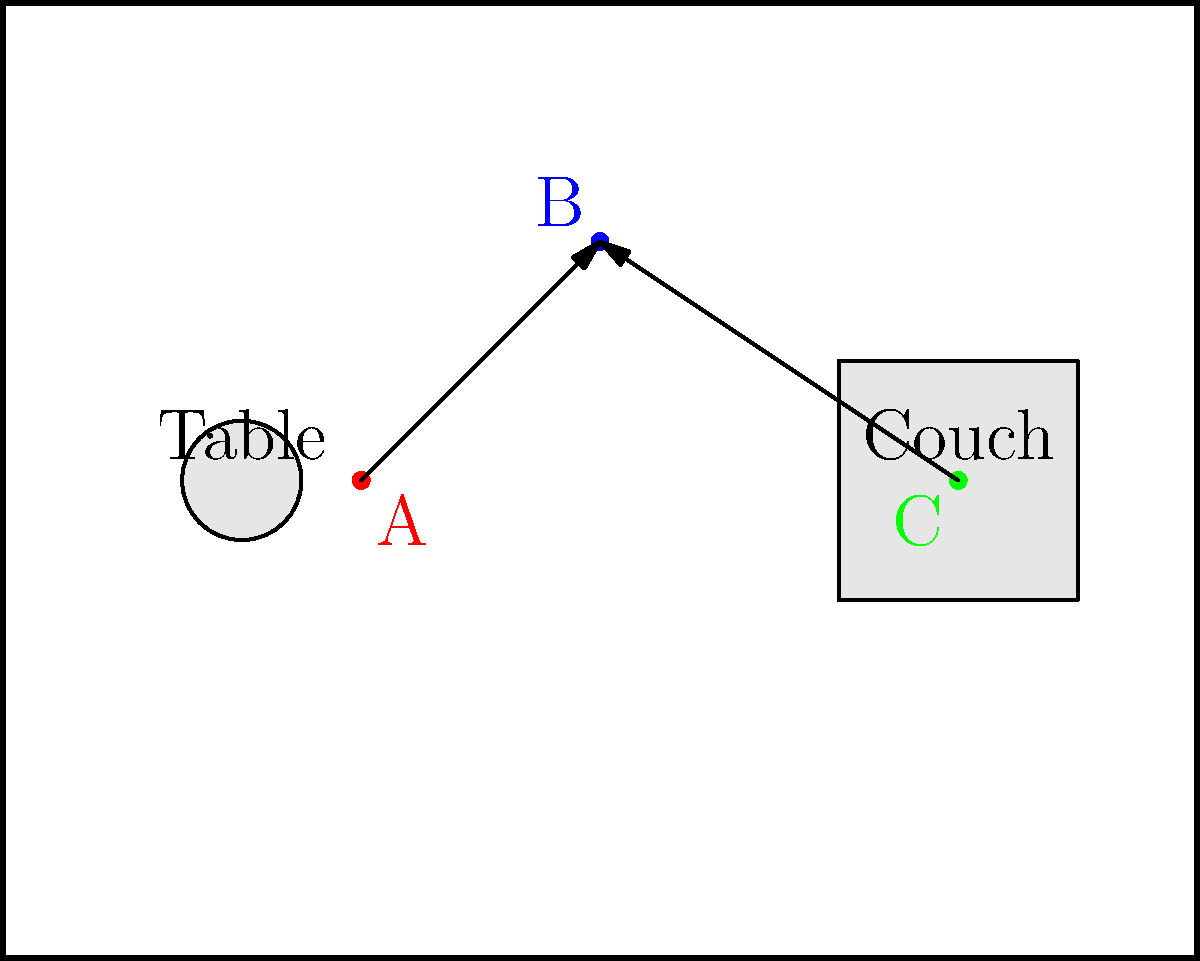In a pivotal scene inspired by Angela Bassett's powerful performances, you're directing three actors (A, B, and C) on stage. Given the top-down diagram of the stage, which shows the initial positions of the actors and key set pieces, describe the optimal blocking for a dramatic confrontation where characters A and C must converge on B. How should their movements be choreographed to maximize tension and visual impact? To create an optimal blocking for this dramatic confrontation, we should consider the following steps:

1. Initial Positions: 
   - Actor A is near the table on stage left.
   - Actor B is upstage center.
   - Actor C is near the couch on stage right.

2. Creating Tension:
   - The goal is to have A and C converge on B, creating a sense of confrontation and pressure.

3. Movement Choreography:
   - Actor A should move diagonally upstage and to the right, towards B.
   - Actor C should move diagonally upstage and to the left, also towards B.
   - These diagonal movements create dynamic lines on stage, enhancing visual interest.

4. Timing:
   - A and C should move simultaneously or in quick succession to increase tension.
   - Their pace can start slow and increase as they approach B.

5. Actor B's Response:
   - As A and C approach, B can take a step or two backward to emphasize feeling cornered.
   - This backward movement also helps maintain sight lines for the audience.

6. Final Positions:
   - The scene should end with A and C flanking B, creating a triangle formation.
   - This formation puts visual focus on B while maintaining the power dynamic of two against one.

7. Use of Set Pieces:
   - The movement should be choreographed to avoid collisions with the table and couch.
   - These obstacles can be used to create natural pauses or moments of tension in the movement.

8. Consideration of Sight Lines:
   - Ensure that no actor completely blocks another from the audience's view in the final position.

By following these steps, the blocking will create a visually dynamic and emotionally tense scene, reminiscent of the powerful confrontations in Angela Bassett's performances.
Answer: A and C move diagonally towards B, creating a triangle formation, with synchronized, increasing pace and strategic use of set pieces for dramatic tension. 